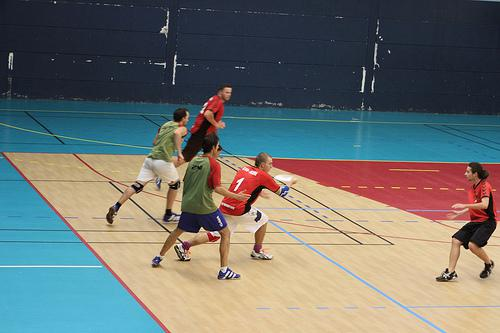Question: when was the picture taken?
Choices:
A. Sunset.
B. In the morning.
C. During a basketball game.
D. Christmas.
Answer with the letter. Answer: C Question: why was the picture taken?
Choices:
A. To capture the players.
B. To capture the animals.
C. To capture the spectators.
D. To capture the coaches.
Answer with the letter. Answer: A Question: what are the people doing?
Choices:
A. Playing basketball.
B. Dancing.
C. Riding horses.
D. Eating.
Answer with the letter. Answer: A Question: where was the picture taken?
Choices:
A. The beach.
B. On a basketball court.
C. A mountain.
D. Hawaii.
Answer with the letter. Answer: B Question: who is in the picture?
Choices:
A. Spectators.
B. Players.
C. Coaches.
D. Referees.
Answer with the letter. Answer: B 